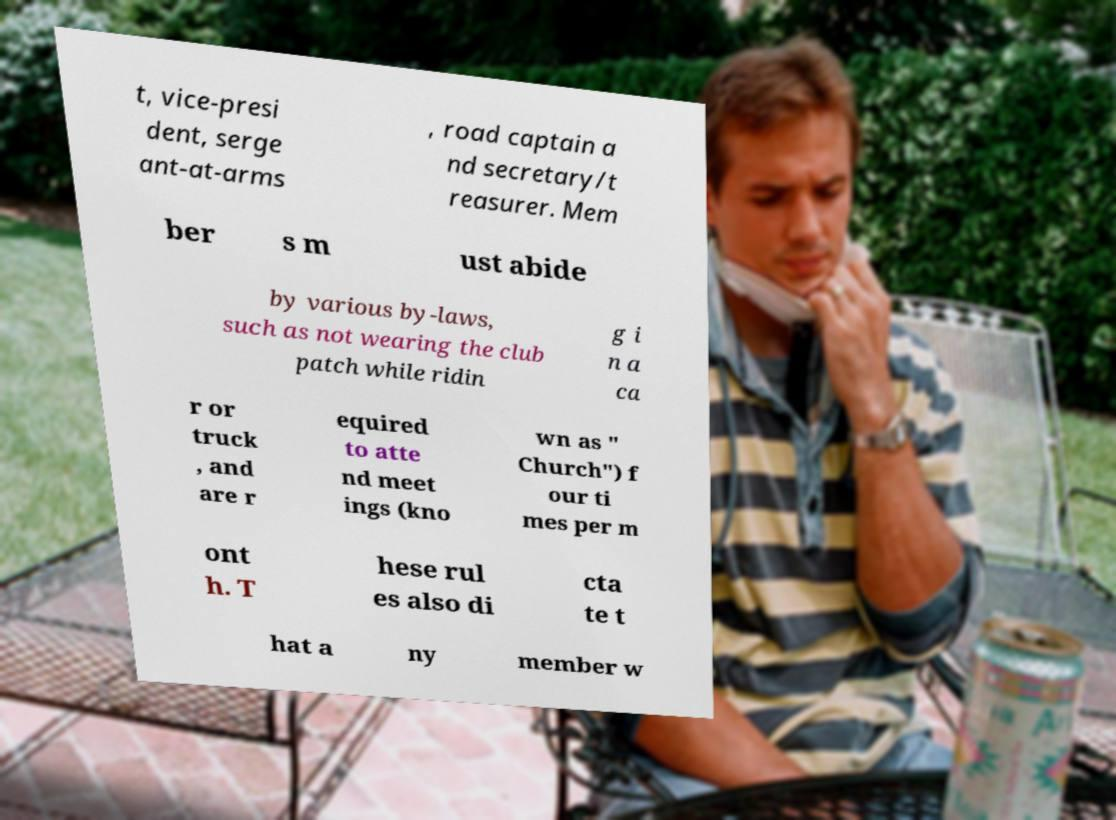I need the written content from this picture converted into text. Can you do that? t, vice-presi dent, serge ant-at-arms , road captain a nd secretary/t reasurer. Mem ber s m ust abide by various by-laws, such as not wearing the club patch while ridin g i n a ca r or truck , and are r equired to atte nd meet ings (kno wn as " Church") f our ti mes per m ont h. T hese rul es also di cta te t hat a ny member w 